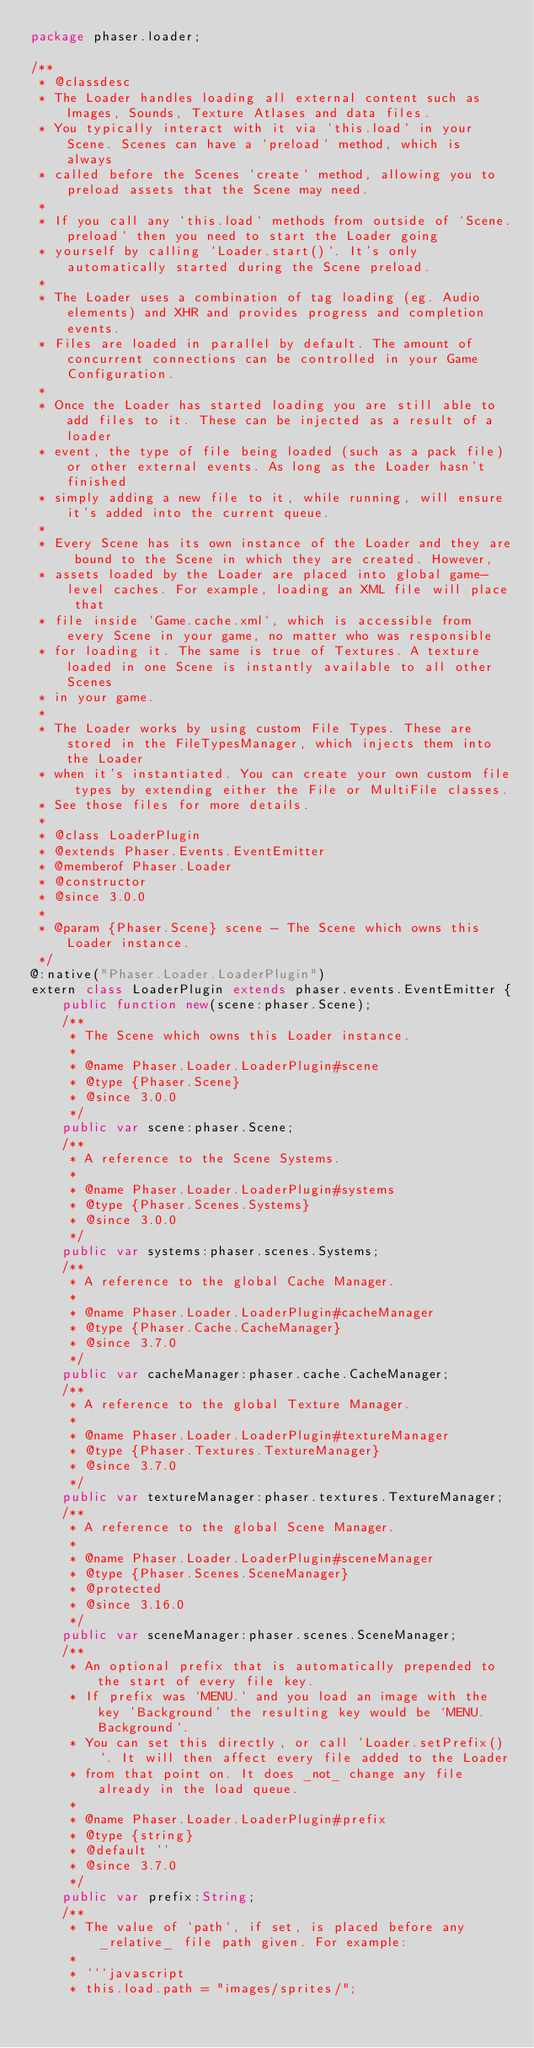Convert code to text. <code><loc_0><loc_0><loc_500><loc_500><_Haxe_>package phaser.loader;

/**
 * @classdesc
 * The Loader handles loading all external content such as Images, Sounds, Texture Atlases and data files.
 * You typically interact with it via `this.load` in your Scene. Scenes can have a `preload` method, which is always
 * called before the Scenes `create` method, allowing you to preload assets that the Scene may need.
 *
 * If you call any `this.load` methods from outside of `Scene.preload` then you need to start the Loader going
 * yourself by calling `Loader.start()`. It's only automatically started during the Scene preload.
 *
 * The Loader uses a combination of tag loading (eg. Audio elements) and XHR and provides progress and completion events.
 * Files are loaded in parallel by default. The amount of concurrent connections can be controlled in your Game Configuration.
 *
 * Once the Loader has started loading you are still able to add files to it. These can be injected as a result of a loader
 * event, the type of file being loaded (such as a pack file) or other external events. As long as the Loader hasn't finished
 * simply adding a new file to it, while running, will ensure it's added into the current queue.
 *
 * Every Scene has its own instance of the Loader and they are bound to the Scene in which they are created. However,
 * assets loaded by the Loader are placed into global game-level caches. For example, loading an XML file will place that
 * file inside `Game.cache.xml`, which is accessible from every Scene in your game, no matter who was responsible
 * for loading it. The same is true of Textures. A texture loaded in one Scene is instantly available to all other Scenes
 * in your game.
 *
 * The Loader works by using custom File Types. These are stored in the FileTypesManager, which injects them into the Loader
 * when it's instantiated. You can create your own custom file types by extending either the File or MultiFile classes.
 * See those files for more details.
 *
 * @class LoaderPlugin
 * @extends Phaser.Events.EventEmitter
 * @memberof Phaser.Loader
 * @constructor
 * @since 3.0.0
 *
 * @param {Phaser.Scene} scene - The Scene which owns this Loader instance.
 */
@:native("Phaser.Loader.LoaderPlugin")
extern class LoaderPlugin extends phaser.events.EventEmitter {
    public function new(scene:phaser.Scene);
    /**
     * The Scene which owns this Loader instance.
     *
     * @name Phaser.Loader.LoaderPlugin#scene
     * @type {Phaser.Scene}
     * @since 3.0.0
     */
    public var scene:phaser.Scene;
    /**
     * A reference to the Scene Systems.
     *
     * @name Phaser.Loader.LoaderPlugin#systems
     * @type {Phaser.Scenes.Systems}
     * @since 3.0.0
     */
    public var systems:phaser.scenes.Systems;
    /**
     * A reference to the global Cache Manager.
     *
     * @name Phaser.Loader.LoaderPlugin#cacheManager
     * @type {Phaser.Cache.CacheManager}
     * @since 3.7.0
     */
    public var cacheManager:phaser.cache.CacheManager;
    /**
     * A reference to the global Texture Manager.
     *
     * @name Phaser.Loader.LoaderPlugin#textureManager
     * @type {Phaser.Textures.TextureManager}
     * @since 3.7.0
     */
    public var textureManager:phaser.textures.TextureManager;
    /**
     * A reference to the global Scene Manager.
     *
     * @name Phaser.Loader.LoaderPlugin#sceneManager
     * @type {Phaser.Scenes.SceneManager}
     * @protected
     * @since 3.16.0
     */
    public var sceneManager:phaser.scenes.SceneManager;
    /**
     * An optional prefix that is automatically prepended to the start of every file key.
     * If prefix was `MENU.` and you load an image with the key 'Background' the resulting key would be `MENU.Background`.
     * You can set this directly, or call `Loader.setPrefix()`. It will then affect every file added to the Loader
     * from that point on. It does _not_ change any file already in the load queue.
     *
     * @name Phaser.Loader.LoaderPlugin#prefix
     * @type {string}
     * @default ''
     * @since 3.7.0
     */
    public var prefix:String;
    /**
     * The value of `path`, if set, is placed before any _relative_ file path given. For example:
     *
     * ```javascript
     * this.load.path = "images/sprites/";</code> 